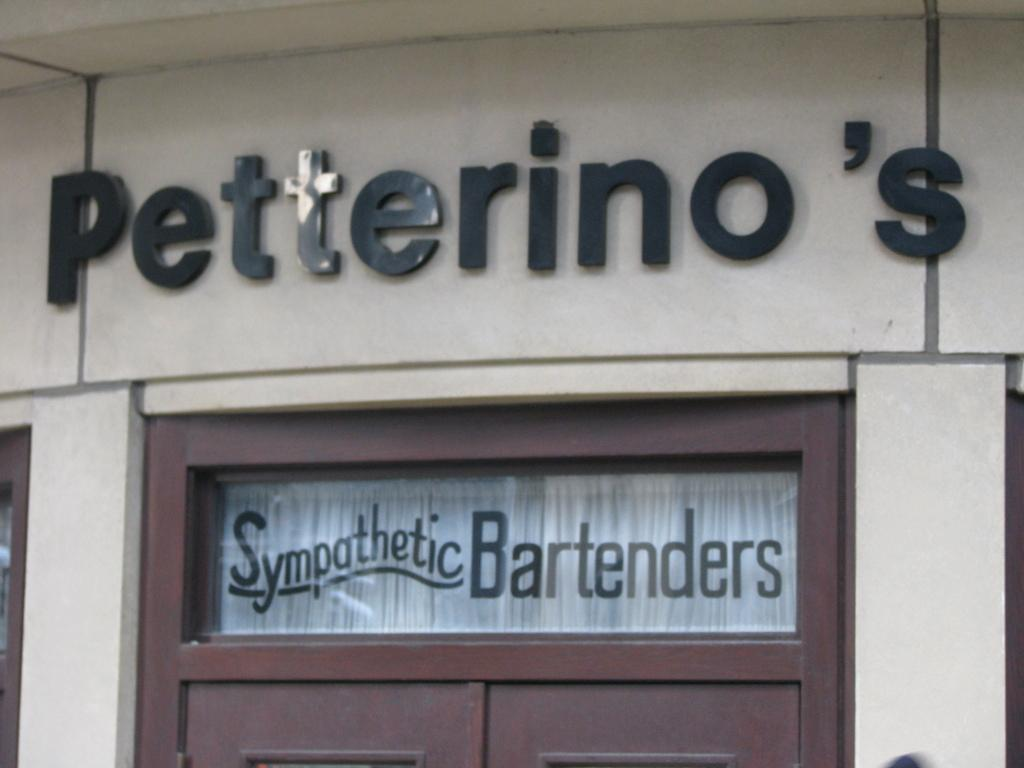What is on the wall in the image? There is a sign board on the wall in the image. What type of door can be seen in the image? There is a wooden door in the image. What is the glass surface with text used for in the image? The glass surface with text is likely used for displaying information or advertisements. What kind of pets are featured in the story on the sign board? There is no story or pets mentioned on the sign board in the image. What sense is being stimulated by the wooden door in the image? The wooden door in the image is not designed to stimulate any specific sense. 